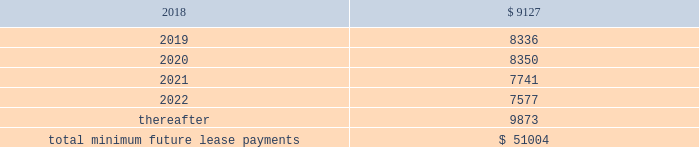As of december 31 , 2017 , the aggregate future minimum payments under non-cancelable operating leases consist of the following ( in thousands ) : years ending december 31 .
Rent expense for all operating leases amounted to $ 9.4 million , $ 8.1 million and $ 5.4 million for the years ended december 31 , 2017 , 2016 and 2015 , respectively .
Financing obligation 2014build-to-suit lease in august 2012 , we executed a lease for a building then under construction in santa clara , california to serve as our headquarters .
The lease term is 120 months and commenced in august 2013 .
Based on the terms of the lease agreement and due to our involvement in certain aspects of the construction , we were deemed the owner of the building ( for accounting purposes only ) during the construction period .
Upon completion of construction in 2013 , we concluded that we had forms of continued economic involvement in the facility , and therefore did not meet with the provisions for sale-leaseback accounting .
We continue to maintain involvement in the property post construction and lack transferability of the risks and rewards of ownership , due to our required maintenance of a $ 4.0 million letter of credit , in addition to our ability and option to sublease our portion of the leased building for fees substantially higher than our base rate .
Therefore , the lease is accounted for as a financing obligation and lease payments will be attributed to ( 1 ) a reduction of the principal financing obligation ; ( 2 ) imputed interest expense ; and ( 3 ) land lease expense , representing an imputed cost to lease the underlying land of the building .
At the conclusion of the initial lease term , we will de-recognize both the net book values of the asset and the remaining financing obligation .
As of december 31 , 2017 and 2016 , we have recorded assets of $ 53.4 million , representing the total costs of the building and improvements incurred , including the costs paid by the lessor ( the legal owner of the building ) and additional improvement costs paid by us , and a corresponding financing obligation of $ 39.6 million and $ 41.2 million , respectively .
As of december 31 , 2017 , $ 1.9 million and $ 37.7 million were recorded as short-term and long-term financing obligations , respectively .
Land lease expense under our lease financing obligation amounted to $ 1.3 million for each of the years ended december 31 , 2017 , 2016 and 2015 respectively. .
What are the total financial obligations as of december 31 , 2107? 
Computations: (1.9 + 37.7)
Answer: 39.6. 